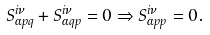<formula> <loc_0><loc_0><loc_500><loc_500>S _ { \alpha p q } ^ { i \nu } + S _ { \alpha q p } ^ { i \nu } = 0 \Rightarrow S _ { \alpha p p } ^ { i \nu } = 0 .</formula> 